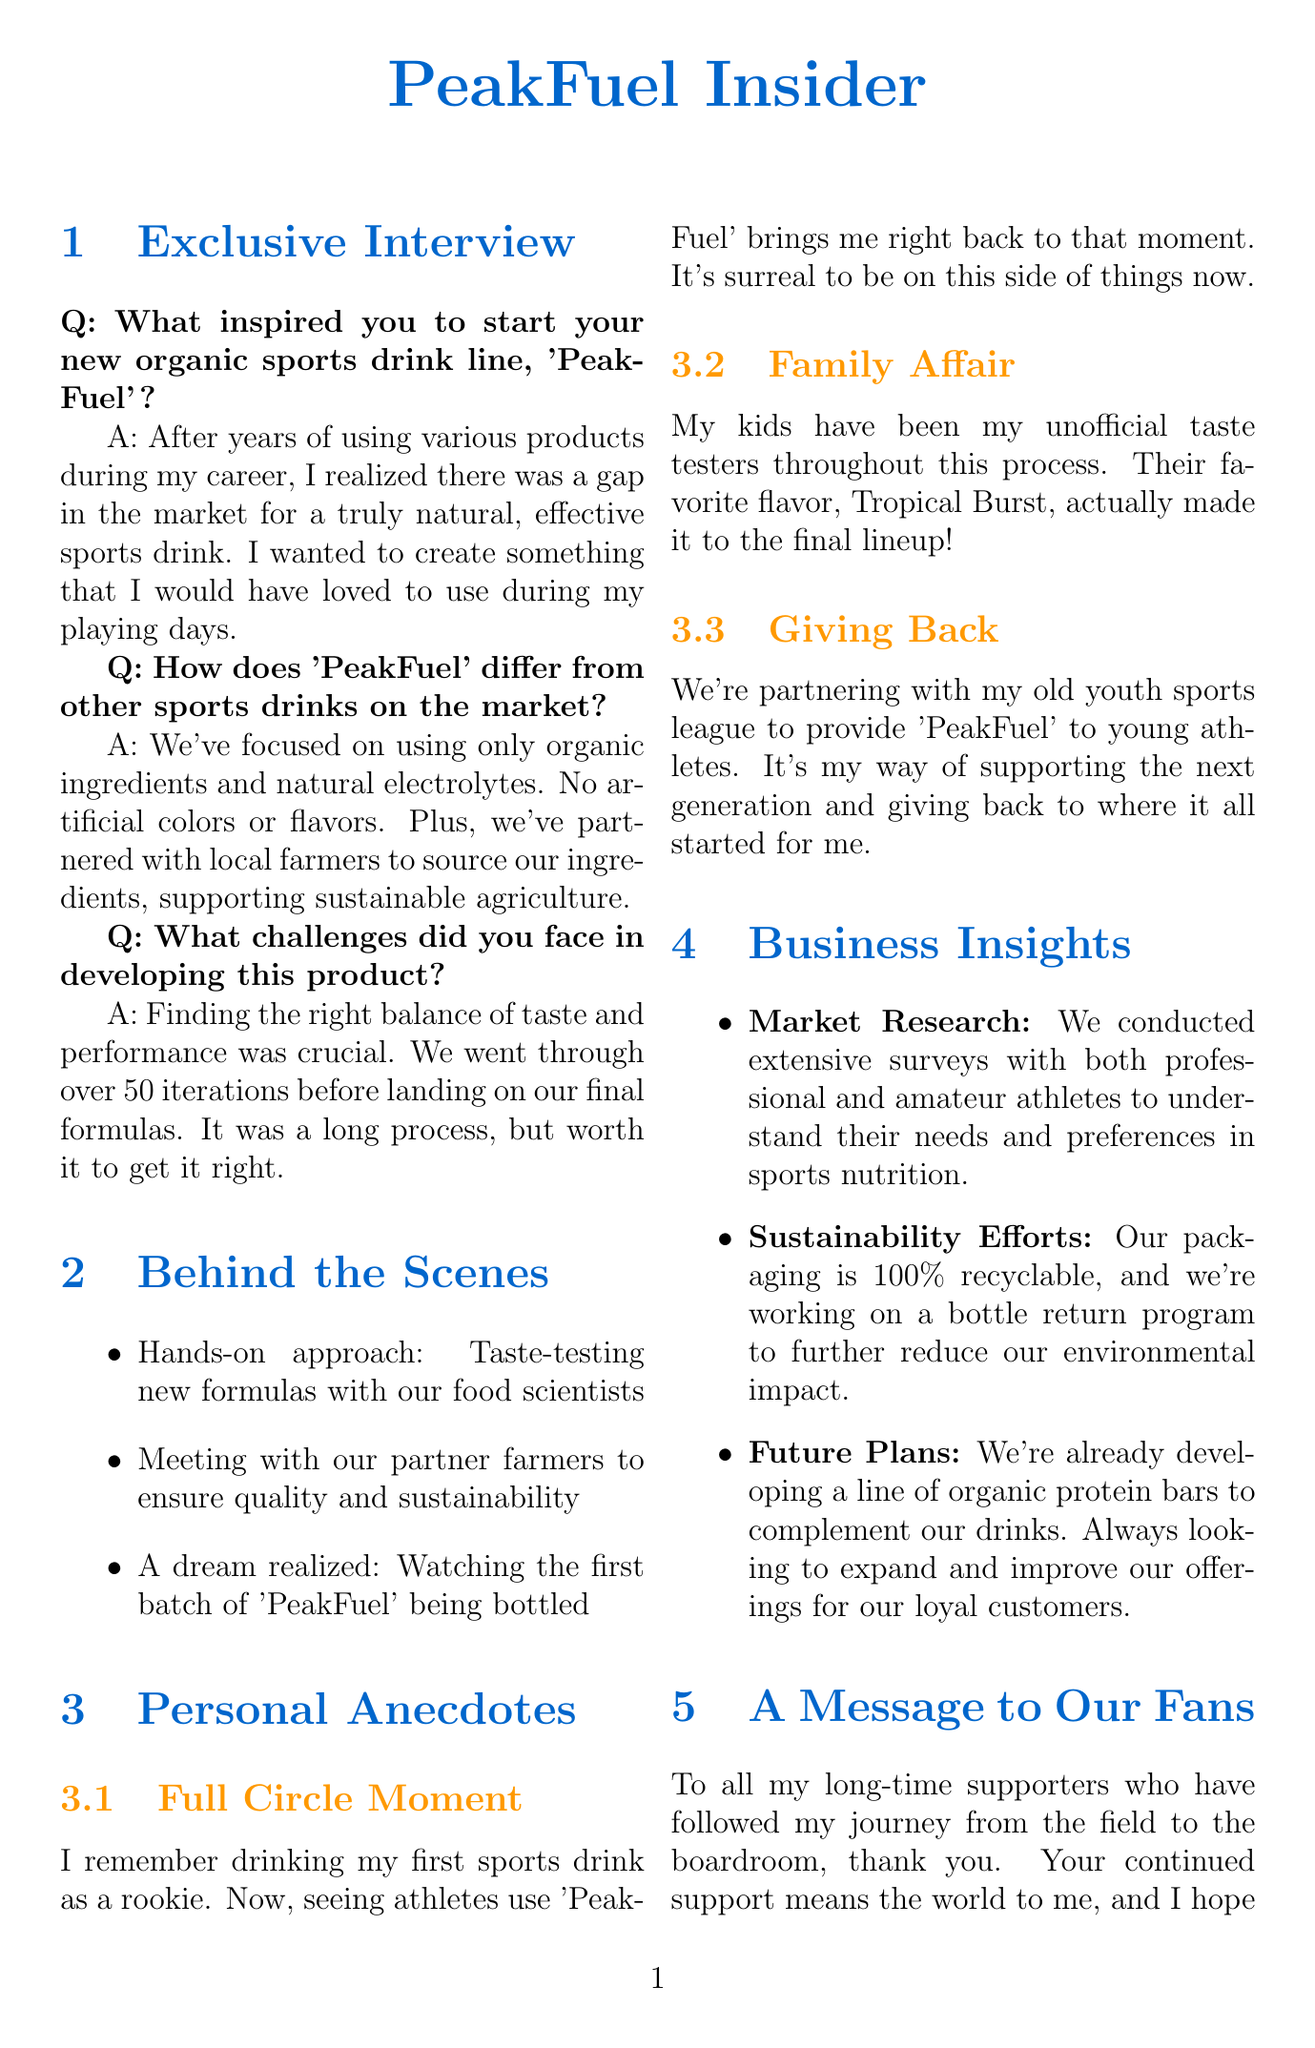What is the name of the new sports drink? The name of the new organic sports drink line is mentioned as 'PeakFuel'.
Answer: PeakFuel How many iterations were made before finalizing the formulas? The document states that over 50 iterations were conducted before landing on the final formulas.
Answer: 50 Which flavor was favored by the athlete's kids? The favorite flavor that made it to the final lineup, as mentioned, is Tropical Burst.
Answer: Tropical Burst What is the packaging material used for 'PeakFuel'? The document specifies that the packaging for 'PeakFuel' is 100% recyclable.
Answer: 100% recyclable What is the discount code for first orders? A special offer discount code for first orders is provided as LOYALFAN.
Answer: LOYALFAN What was the inspiration for starting 'PeakFuel'? The athlete was inspired by a perceived gap in the market for a truly natural, effective sports drink.
Answer: Gap in the market What initiative is mentioned to support young athletes? The document discusses a partnership with the athlete's old youth sports league to provide 'PeakFuel' to young athletes.
Answer: Youth sports league What is the athlete's approach to sourcing ingredients? The athlete partnered with local farmers to source ingredients for 'PeakFuel'.
Answer: Local farmers What are the future plans for 'PeakFuel'? The document mentions plans to develop a line of organic protein bars to complement the drinks.
Answer: Organic protein bars 